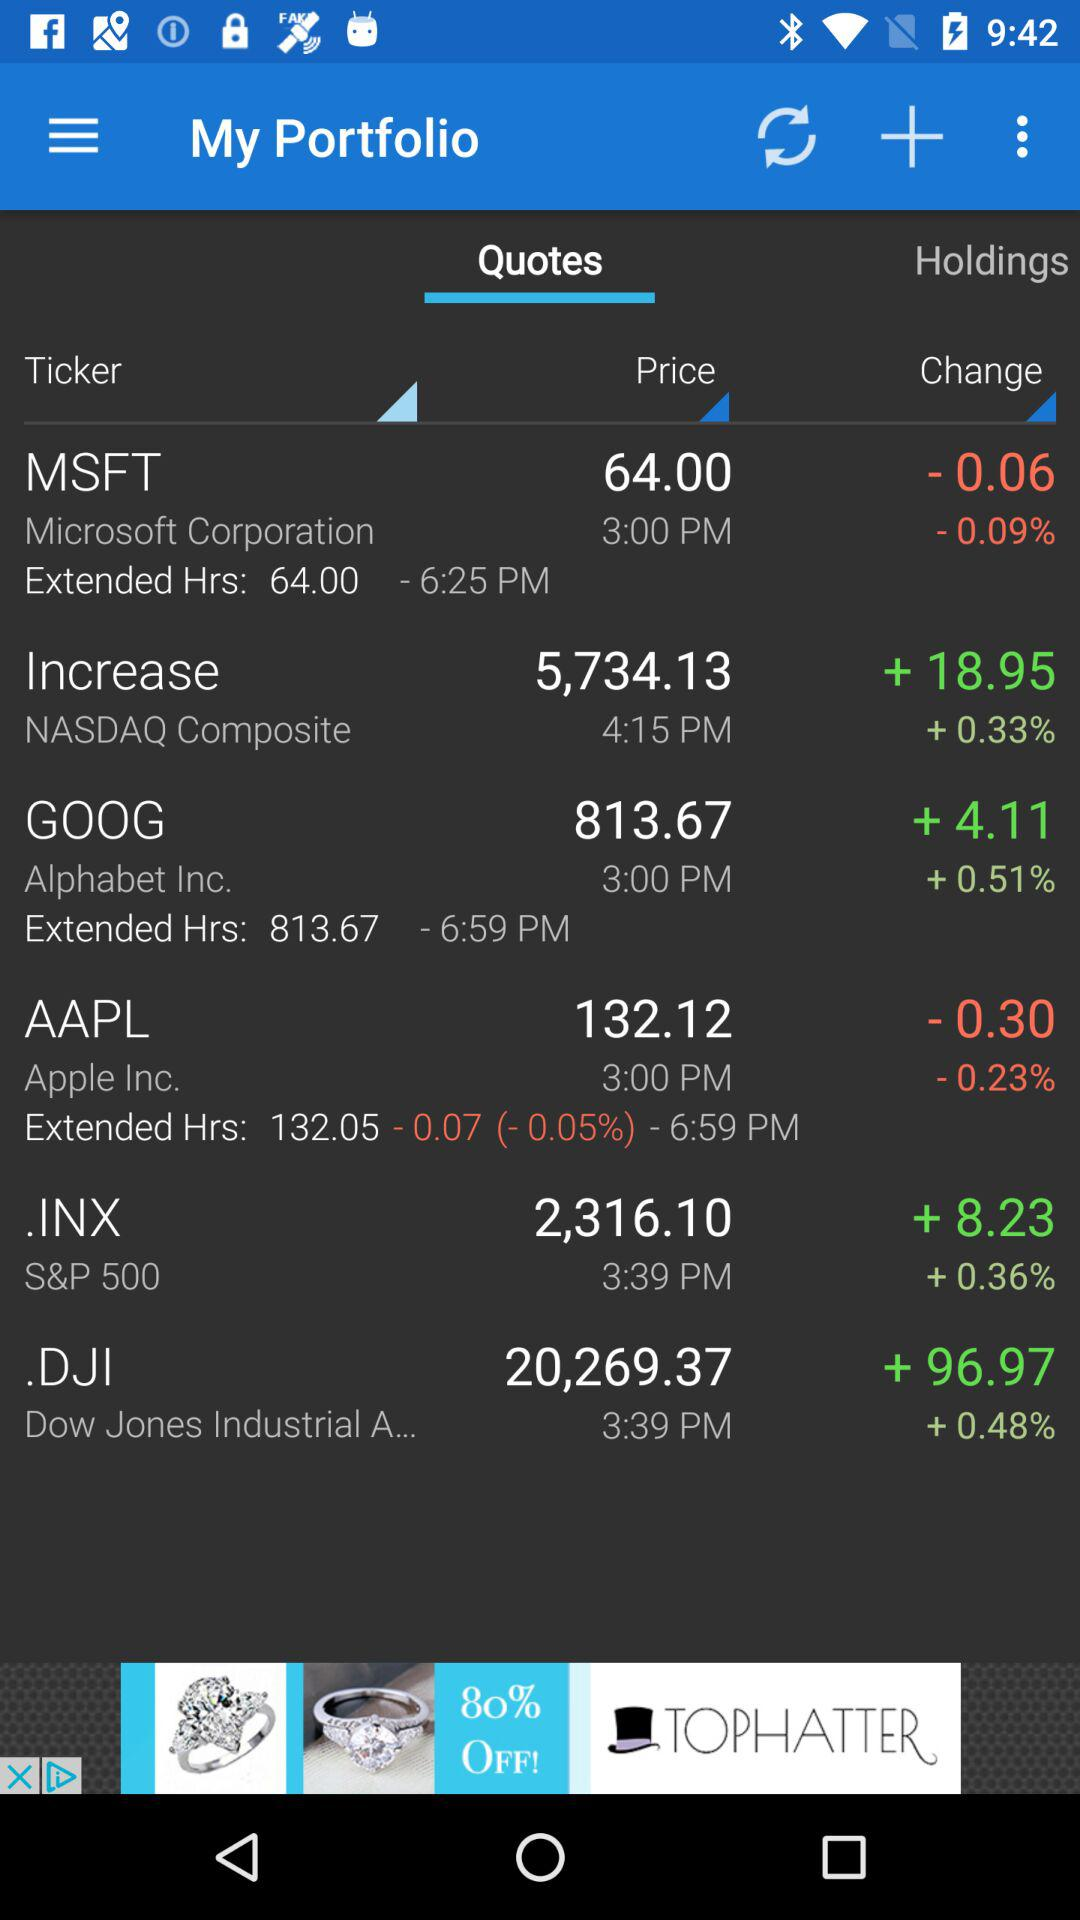What is the application name? The application name is "My Portfolio". 